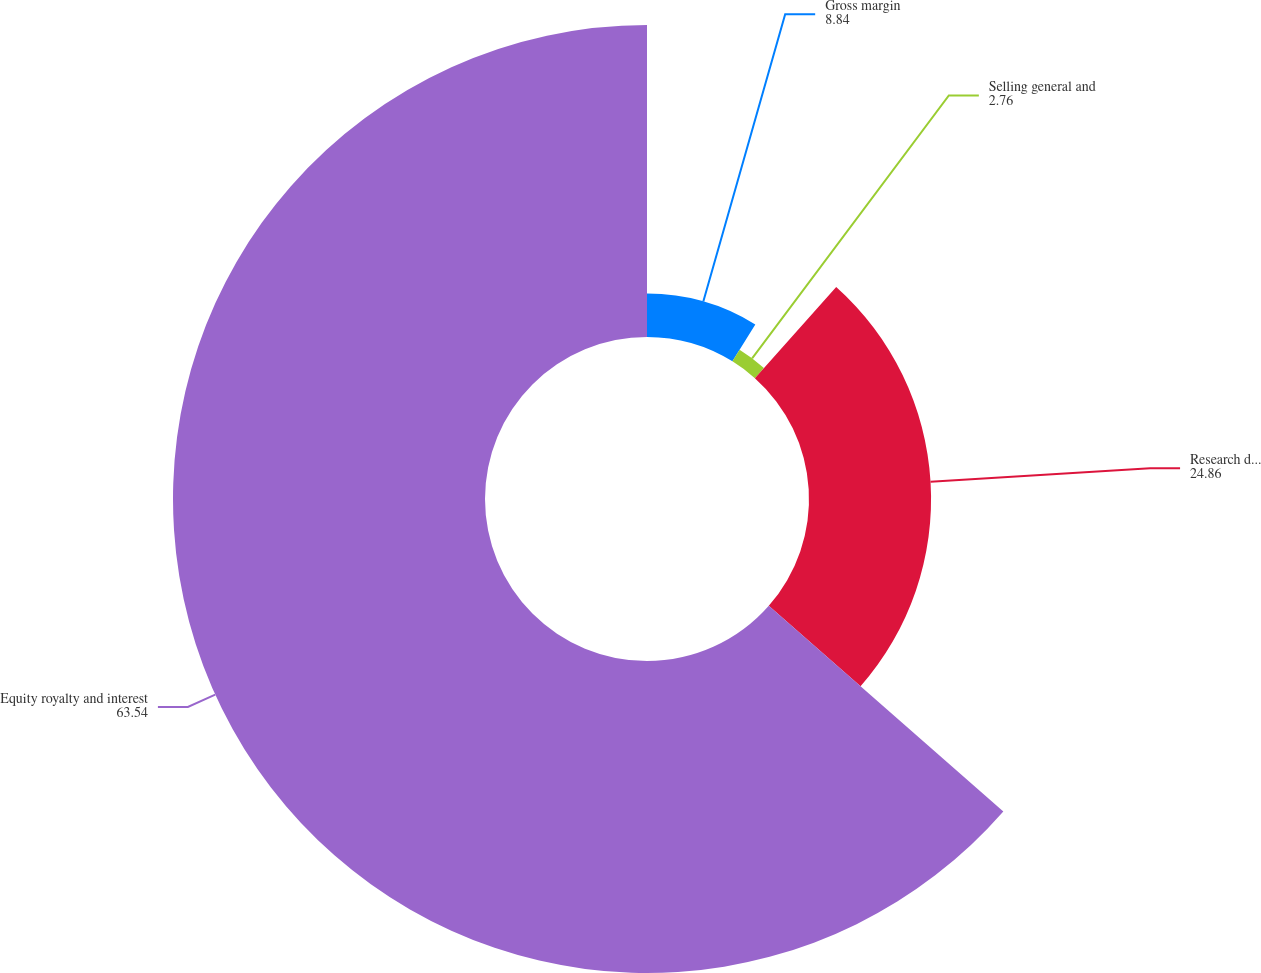Convert chart to OTSL. <chart><loc_0><loc_0><loc_500><loc_500><pie_chart><fcel>Gross margin<fcel>Selling general and<fcel>Research development and<fcel>Equity royalty and interest<nl><fcel>8.84%<fcel>2.76%<fcel>24.86%<fcel>63.54%<nl></chart> 